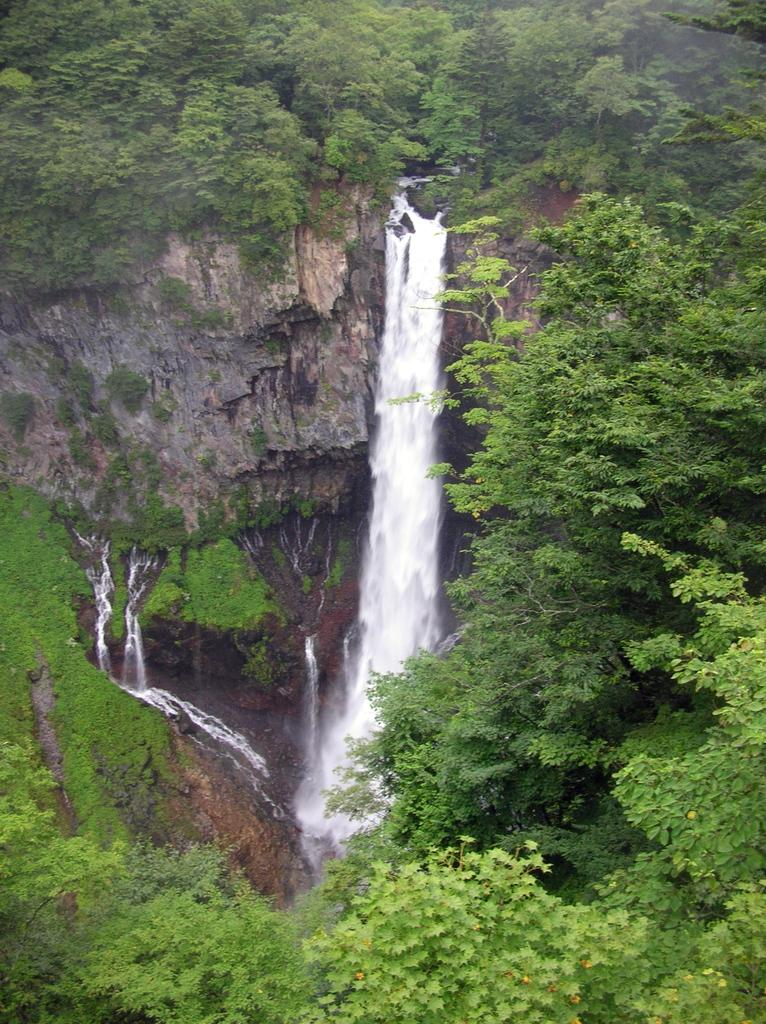What natural feature is the main subject of the image? There is a waterfall in the image. What type of vegetation can be seen around the waterfall? There are trees surrounding the waterfall in the image. What level of agreement is reached between the trees in the image? There is no indication of any agreement or discussion between the trees in the image; they are simply surrounding the waterfall. 